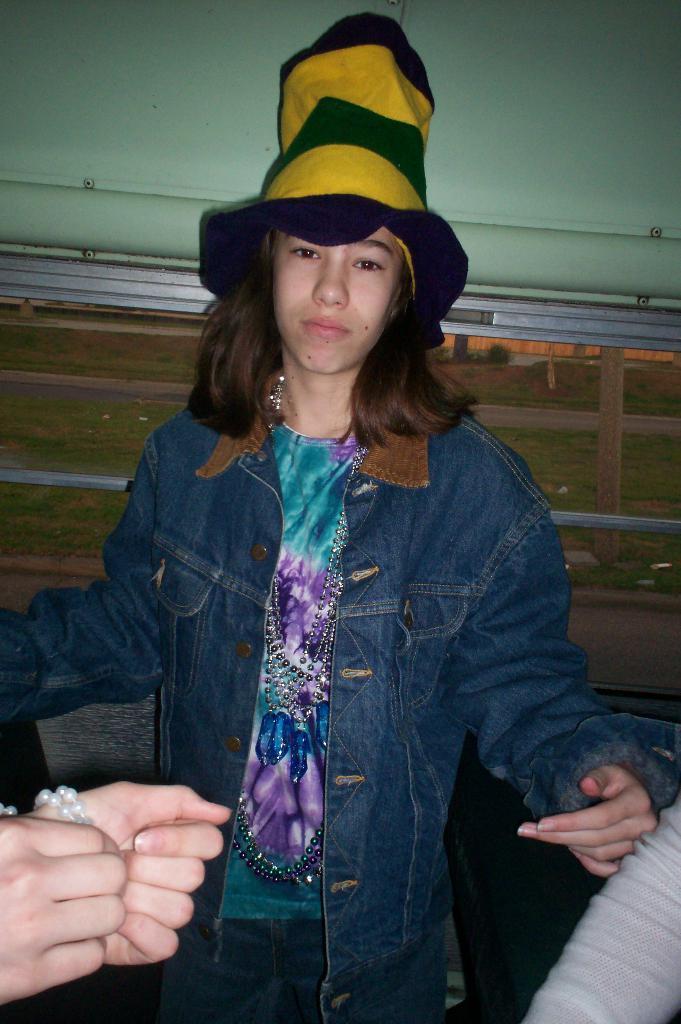In one or two sentences, can you explain what this image depicts? In this picture I can see a person is wearing a jacket and standing. In the background I can see some other objects. Here I can see a person's hand. 